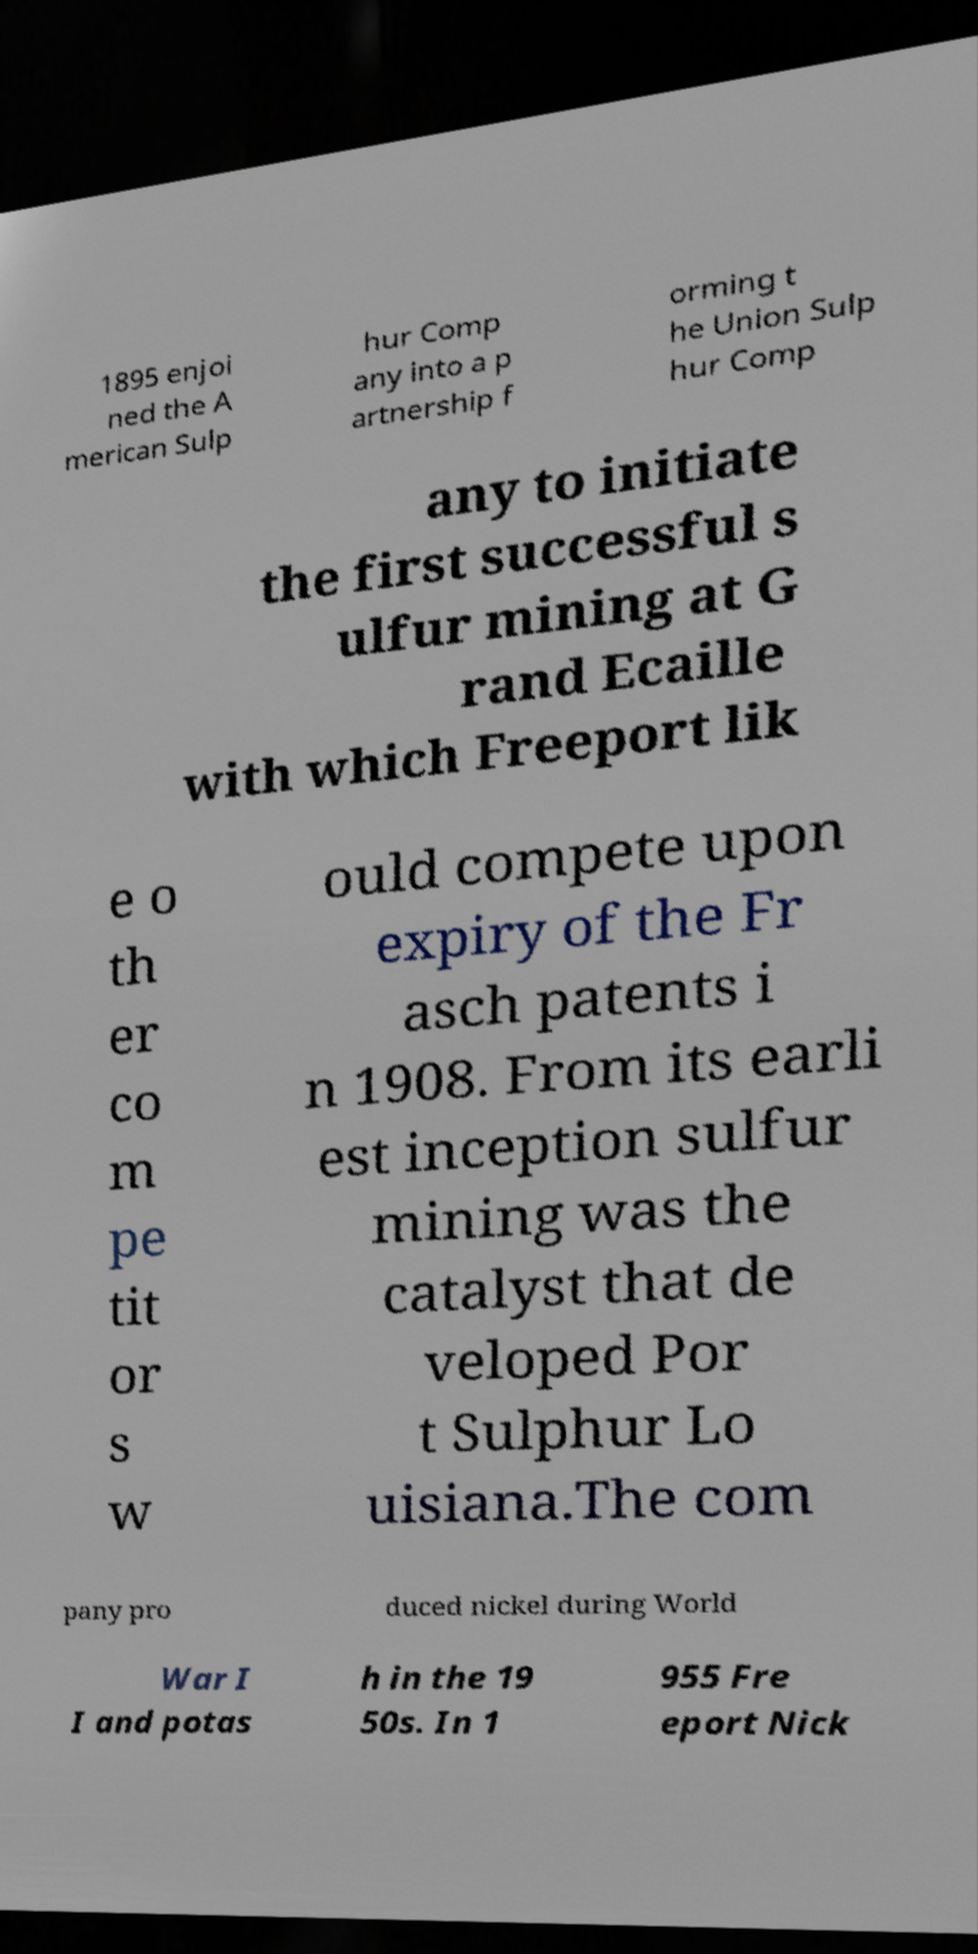I need the written content from this picture converted into text. Can you do that? 1895 enjoi ned the A merican Sulp hur Comp any into a p artnership f orming t he Union Sulp hur Comp any to initiate the first successful s ulfur mining at G rand Ecaille with which Freeport lik e o th er co m pe tit or s w ould compete upon expiry of the Fr asch patents i n 1908. From its earli est inception sulfur mining was the catalyst that de veloped Por t Sulphur Lo uisiana.The com pany pro duced nickel during World War I I and potas h in the 19 50s. In 1 955 Fre eport Nick 